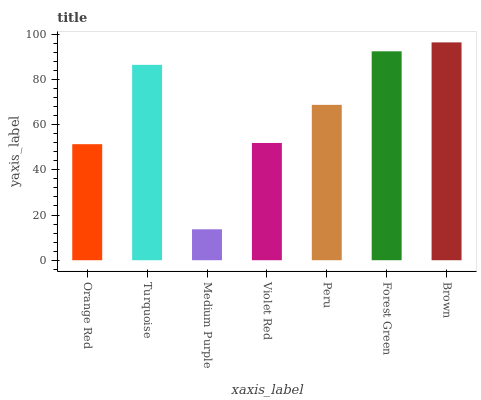Is Medium Purple the minimum?
Answer yes or no. Yes. Is Brown the maximum?
Answer yes or no. Yes. Is Turquoise the minimum?
Answer yes or no. No. Is Turquoise the maximum?
Answer yes or no. No. Is Turquoise greater than Orange Red?
Answer yes or no. Yes. Is Orange Red less than Turquoise?
Answer yes or no. Yes. Is Orange Red greater than Turquoise?
Answer yes or no. No. Is Turquoise less than Orange Red?
Answer yes or no. No. Is Peru the high median?
Answer yes or no. Yes. Is Peru the low median?
Answer yes or no. Yes. Is Brown the high median?
Answer yes or no. No. Is Medium Purple the low median?
Answer yes or no. No. 